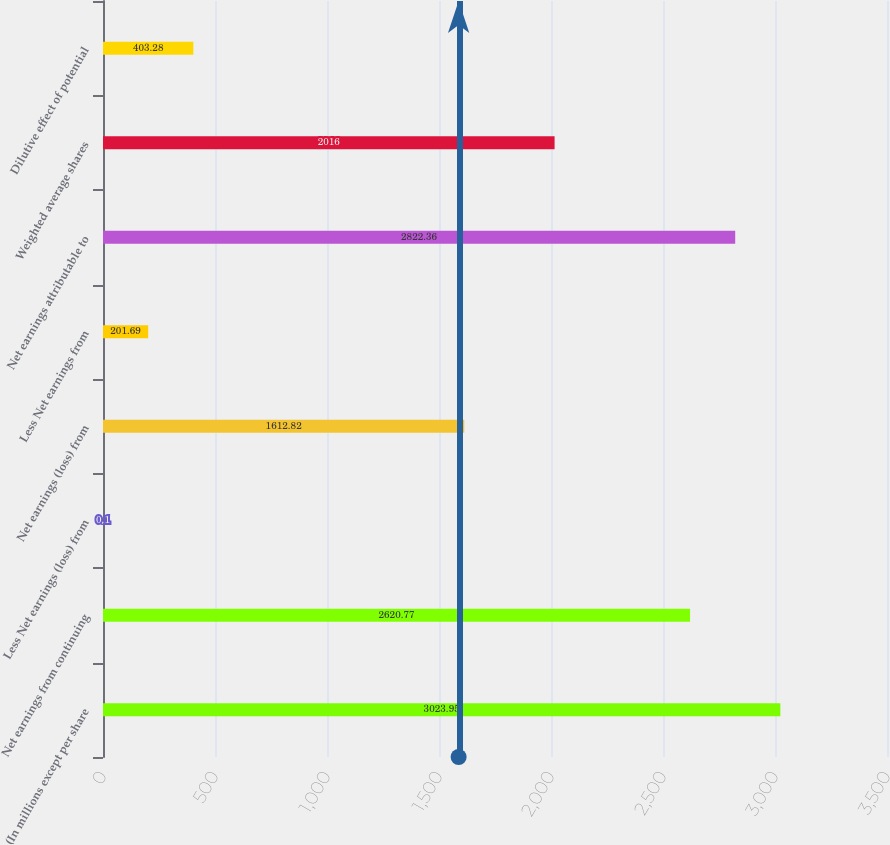Convert chart to OTSL. <chart><loc_0><loc_0><loc_500><loc_500><bar_chart><fcel>(In millions except per share<fcel>Net earnings from continuing<fcel>Less Net earnings (loss) from<fcel>Net earnings (loss) from<fcel>Less Net earnings from<fcel>Net earnings attributable to<fcel>Weighted average shares<fcel>Dilutive effect of potential<nl><fcel>3023.95<fcel>2620.77<fcel>0.1<fcel>1612.82<fcel>201.69<fcel>2822.36<fcel>2016<fcel>403.28<nl></chart> 